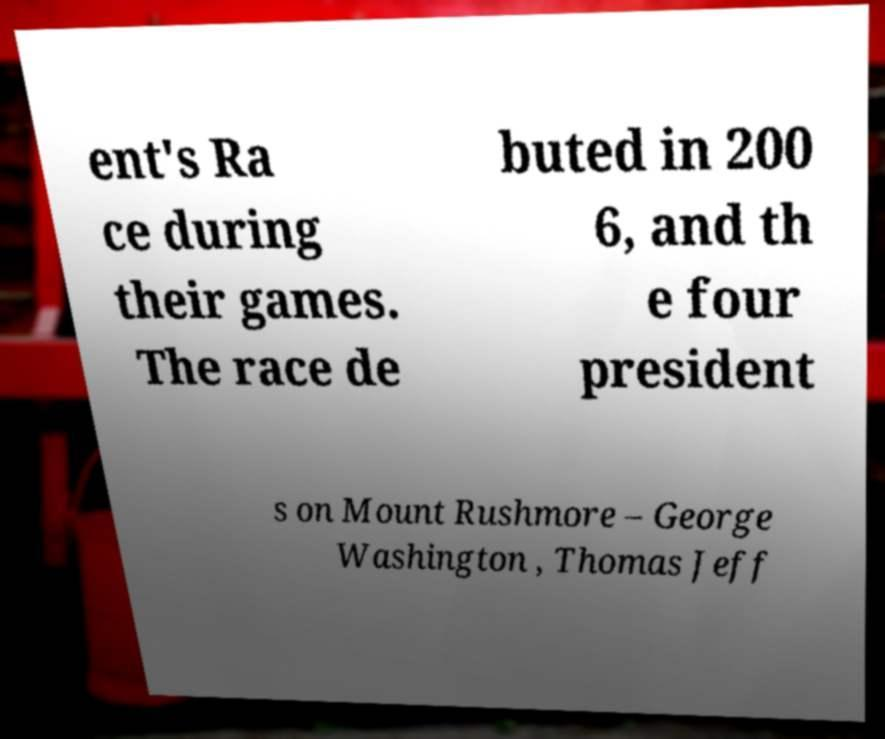For documentation purposes, I need the text within this image transcribed. Could you provide that? ent's Ra ce during their games. The race de buted in 200 6, and th e four president s on Mount Rushmore – George Washington , Thomas Jeff 